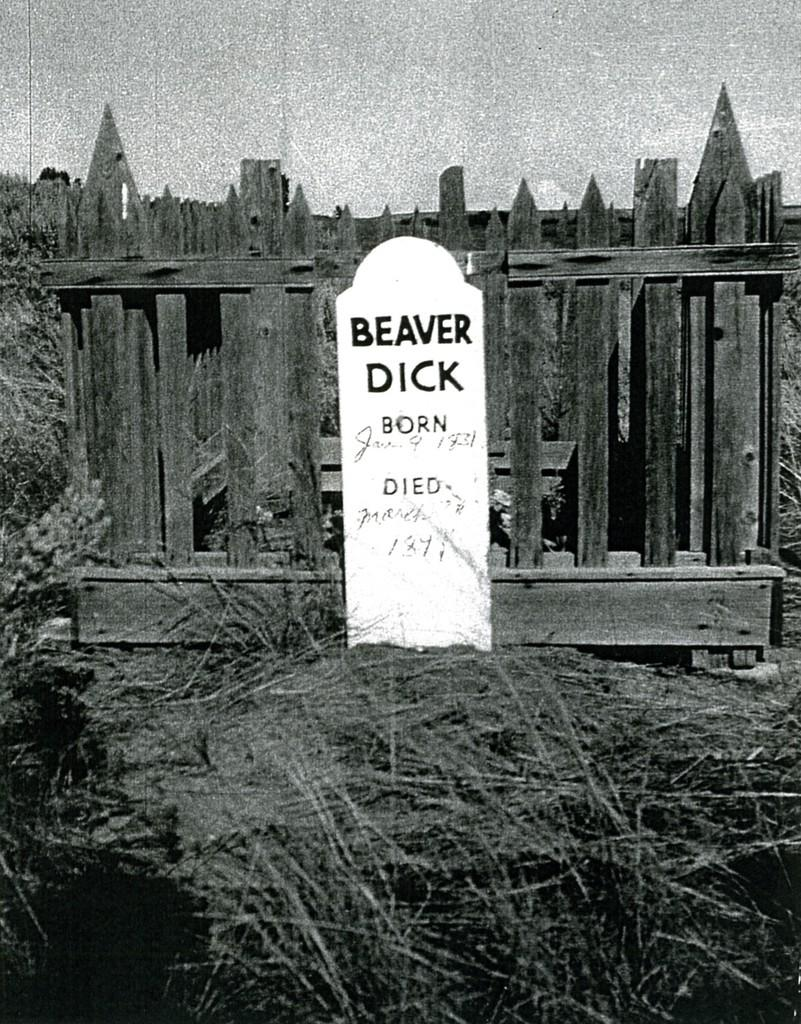What is the color scheme of the image? The image is black and white. What is the main subject of the image? There is a tomb in the image. What can be seen on the tomb's stone? There is text on the stone of the tomb. What is located behind the tomb? There is a fence visible on the backside of the tomb. What is visible in the sky in the image? The sky is visible in the image. What type of pump is visible in the image? There is no pump present in the image. Can you tell me how many ears of corn are on the tomb? There are no ears of corn present in the image. 